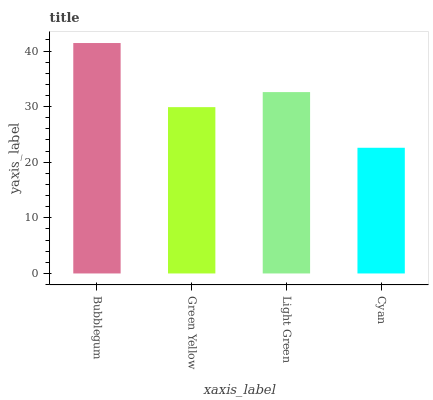Is Green Yellow the minimum?
Answer yes or no. No. Is Green Yellow the maximum?
Answer yes or no. No. Is Bubblegum greater than Green Yellow?
Answer yes or no. Yes. Is Green Yellow less than Bubblegum?
Answer yes or no. Yes. Is Green Yellow greater than Bubblegum?
Answer yes or no. No. Is Bubblegum less than Green Yellow?
Answer yes or no. No. Is Light Green the high median?
Answer yes or no. Yes. Is Green Yellow the low median?
Answer yes or no. Yes. Is Green Yellow the high median?
Answer yes or no. No. Is Cyan the low median?
Answer yes or no. No. 